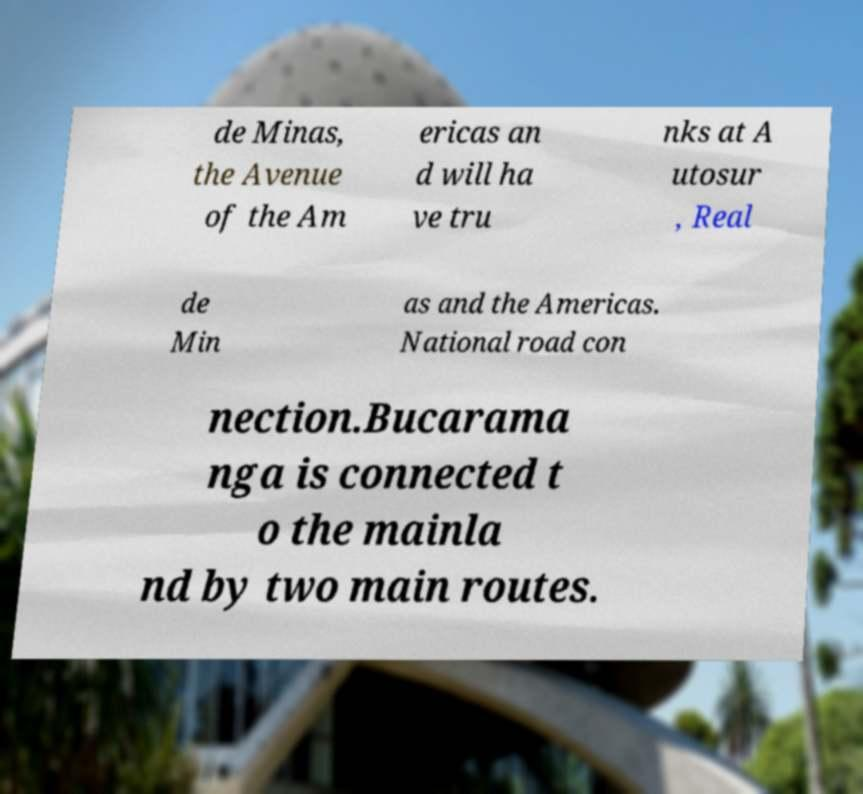There's text embedded in this image that I need extracted. Can you transcribe it verbatim? de Minas, the Avenue of the Am ericas an d will ha ve tru nks at A utosur , Real de Min as and the Americas. National road con nection.Bucarama nga is connected t o the mainla nd by two main routes. 